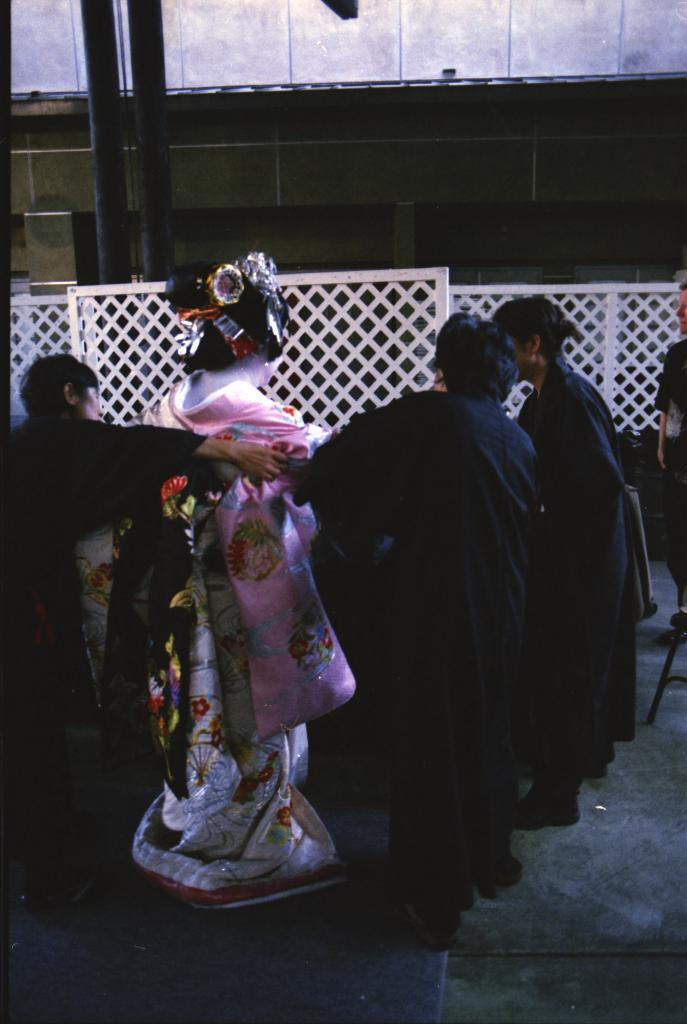What are the persons in the image doing? The persons in the image are standing on the ground. Can you describe the person in the costume? Yes, there is a person in a costume in the image. What is in front of the persons? There is a fence, rods, pillars, and a wall in front of the persons. What type of jail can be seen in the image? There is no jail present in the image. What is the porter carrying in the image? There is no porter present in the image. 